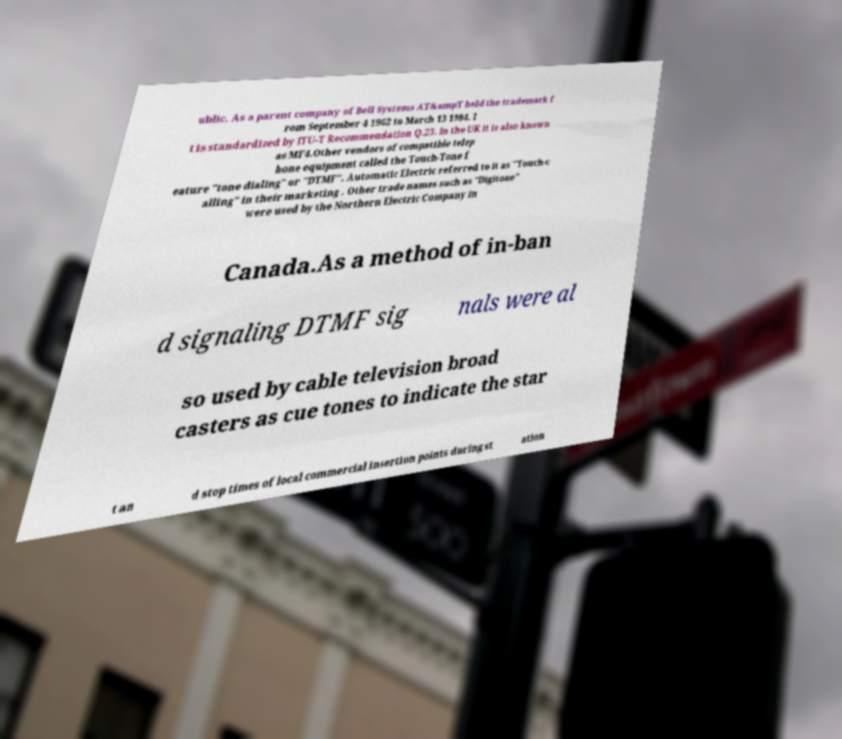Could you extract and type out the text from this image? ublic. As a parent company of Bell Systems AT&ampT held the trademark f rom September 4 1962 to March 13 1984. I t is standardized by ITU-T Recommendation Q.23. In the UK it is also known as MF4.Other vendors of compatible telep hone equipment called the Touch-Tone f eature "tone dialing" or "DTMF". Automatic Electric referred to it as "Touch-c alling" in their marketing . Other trade names such as "Digitone" were used by the Northern Electric Company in Canada.As a method of in-ban d signaling DTMF sig nals were al so used by cable television broad casters as cue tones to indicate the star t an d stop times of local commercial insertion points during st ation 